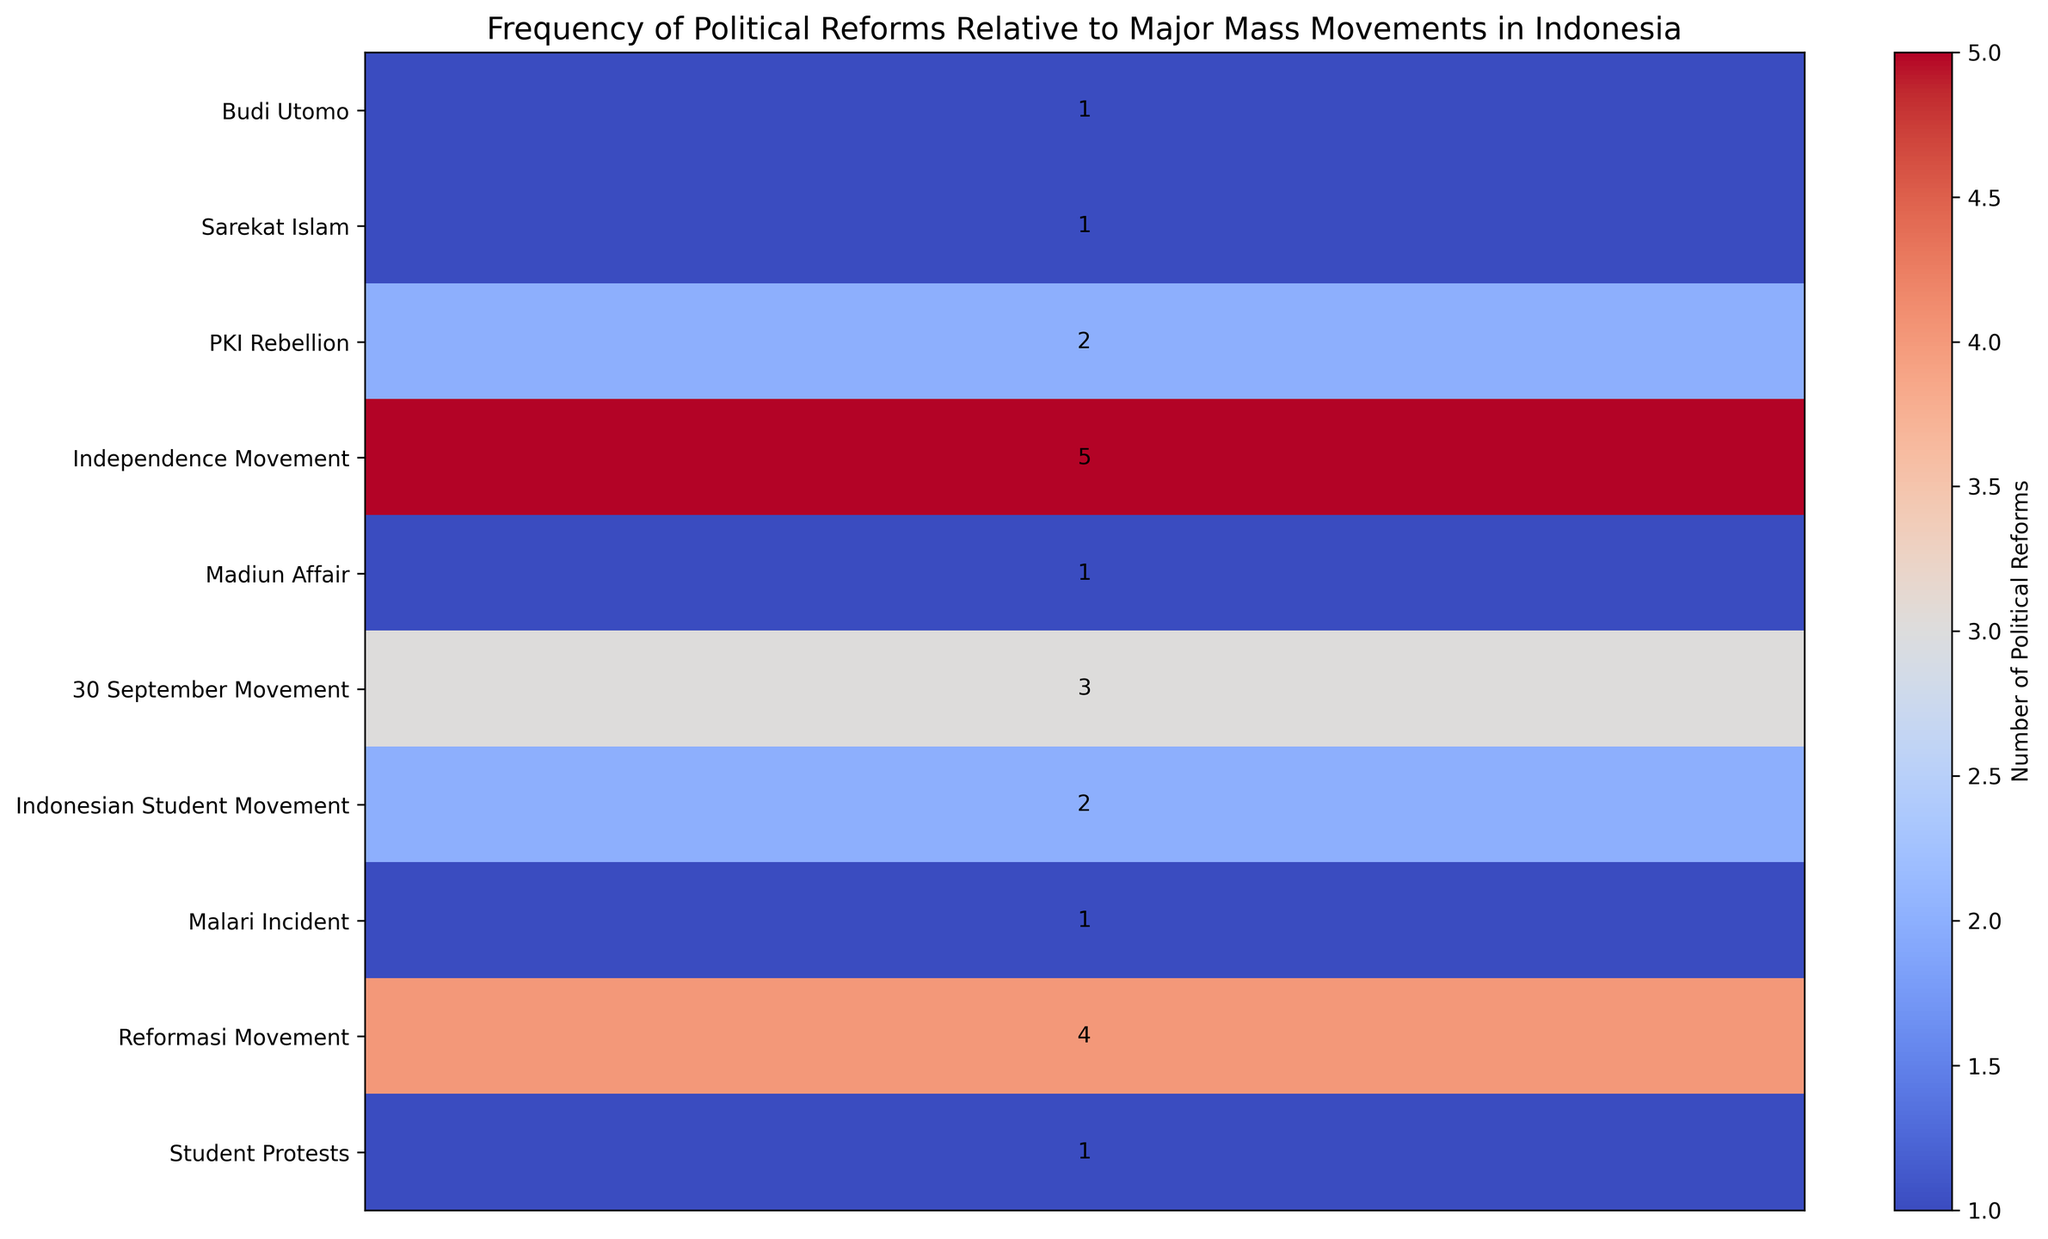Which movement had the highest frequency of political reforms? The heatmap visually shows that the 'Independence Movement' in 1945 has the highest frequency of political reforms, indicated by the highest number (5).
Answer: Independence Movement How many political reforms were associated with the PKI Rebellion and the 30 September Movement combined? The heatmap shows that the PKI Rebellion had 2 political reforms and the 30 September Movement had 3. Adding these together, 2 + 3 = 5.
Answer: 5 Which major mass movement had the lowest frequency of political reforms? Several movements have a frequency of 1 political reform which is the lowest. These movements are 'Budi Utomo', 'Sarekat Islam', 'Madiun Affair', 'Malari Incident', and 'Student Protests'.
Answer: Budi Utomo, Sarekat Islam, Madiun Affair, Malari Incident, Student Protests Is the number of political reforms associated with the Reformasi Movement greater than, less than, or equal to those associated with the Indonesian Student Movement? The number of political reforms for the Reformasi Movement is 4, while that for the Indonesian Student Movement is 2. 4 is greater than 2.
Answer: Greater than Which decades saw the largest number of political reforms according to the heatmap? Analyzing the years, the 1940s had 5 political reforms, 1960s had 5 (3 from 30 September Movement and 2 from Indonesian Student Movement), and 1990s had 4 from the Reformasi Movement. The 1940s and 1960s had the largest number.
Answer: 1940s and 1960s How does the frequency of political reforms in the 2019 student protests compare to the 1966 Indonesian Student Movement? The heatmap shows the 2019 Student Protests had 1 reform, while the 1966 Indonesian Student Movement had 2. 1 is less than 2.
Answer: Less than What is the total number of political reforms shown in the heatmap? Summing up all the numbers in the heatmap: 1 (Budi Utomo) + 1 (Sarekat Islam) + 2 (PKI Rebellion) + 5 (Independence Movement) + 1 (Madiun Affair) + 3 (30 September Movement) + 2 (Indonesian Student Movement) + 1 (Malari Incident) + 4 (Reformasi Movement) + 1 (Student Protests) = 21.
Answer: 21 How many political reforms took place before Indonesia's Independence Movement in 1945? The movements before 1945 include 'Budi Utomo' (1), 'Sarekat Islam' (1), and 'PKI Rebellion' (2). Adding these gives 1 + 1 + 2 = 4.
Answer: 4 